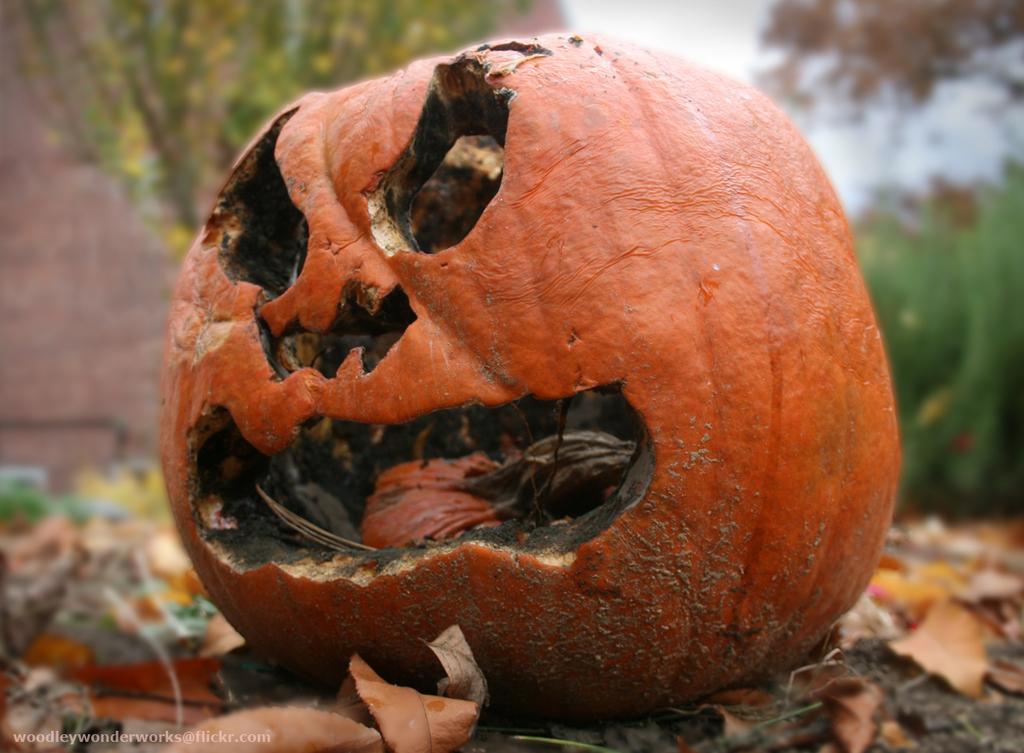Can you describe this image briefly? In the center of the image there is a pumpkin. At the bottom of the image there are dry leaves. In the background of the image there are trees. 